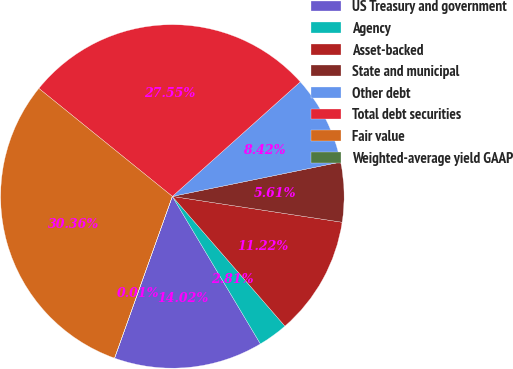Convert chart. <chart><loc_0><loc_0><loc_500><loc_500><pie_chart><fcel>US Treasury and government<fcel>Agency<fcel>Asset-backed<fcel>State and municipal<fcel>Other debt<fcel>Total debt securities<fcel>Fair value<fcel>Weighted-average yield GAAP<nl><fcel>14.02%<fcel>2.81%<fcel>11.22%<fcel>5.61%<fcel>8.42%<fcel>27.55%<fcel>30.36%<fcel>0.01%<nl></chart> 